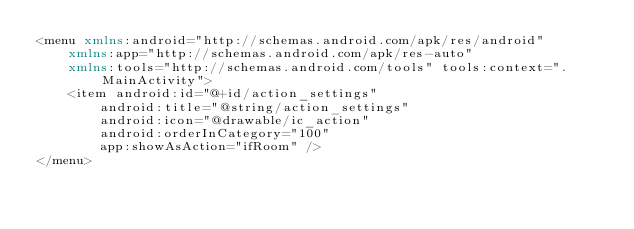Convert code to text. <code><loc_0><loc_0><loc_500><loc_500><_XML_><menu xmlns:android="http://schemas.android.com/apk/res/android"
    xmlns:app="http://schemas.android.com/apk/res-auto"
    xmlns:tools="http://schemas.android.com/tools" tools:context=".MainActivity">
    <item android:id="@+id/action_settings"
        android:title="@string/action_settings"
        android:icon="@drawable/ic_action"
        android:orderInCategory="100"
        app:showAsAction="ifRoom" />
</menu>
</code> 